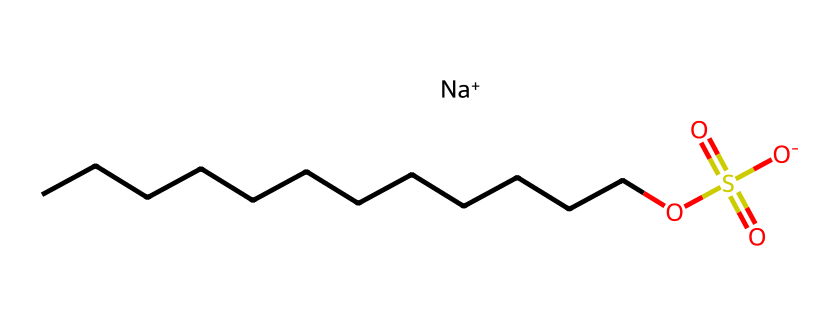What is the total number of carbon atoms in sodium lauryl sulfate? The SMILES representation indicates the presence of a continuous chain of carbon atoms (represented by 'C'). Counting the 'C' characters in succession, we find there are 12 carbon atoms in total.
Answer: 12 Which functional group is responsible for the surfactant properties of sodium lauryl sulfate? In the chemical structure, the presence of the sulfate group (indicated by 'OS(=O)(=O)[O-]') is critical for its surfactant properties, providing the anionic character that helps with emulsification and lowering surface tension.
Answer: sulfate group What is the oxidation state of the sulfur in sodium lauryl sulfate? To determine the oxidation state, we analyze the connections: sulfur is connected to three oxygen atoms and one carbon chain, following the common rules where each oxygen in a sulfate contributes a -2 and considering the overall neutrality, the sulfur is in the +6 oxidation state.
Answer: +6 How many oxygen atoms are present in sodium lauryl sulfate? From the SMILES representation, there are three oxygen atoms indicated by the 'O' characters connected to the sulfur atom, which confirms their presence in the compound.
Answer: 3 What charge does the sodium ion carry in sodium lauryl sulfate? In the chemical structure, the sodium ion is represented as '[Na+]', indicating that it carries a positive one charge, necessary for balancing the negative charge of the sulfate group.
Answer: +1 What type of surfactant is sodium lauryl sulfate classified as? Given its chemical structure and the presence of a sulfate group, sodium lauryl sulfate is classified as an anionic surfactant, characterized by the negatively charged sulfate ion.
Answer: anionic surfactant 